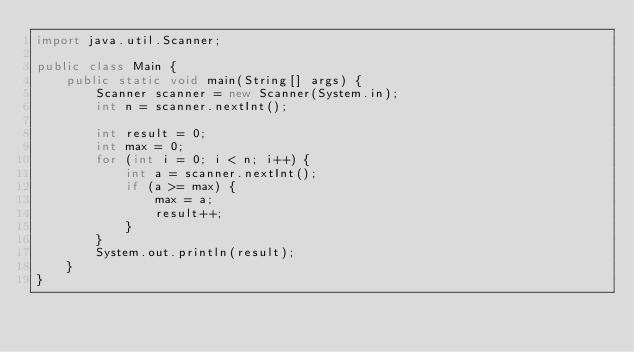<code> <loc_0><loc_0><loc_500><loc_500><_Java_>import java.util.Scanner;

public class Main {
    public static void main(String[] args) {
        Scanner scanner = new Scanner(System.in);
        int n = scanner.nextInt();

        int result = 0;
        int max = 0;
        for (int i = 0; i < n; i++) {
            int a = scanner.nextInt();
            if (a >= max) {
                max = a;
                result++;
            }
        }
        System.out.println(result);
    }
}
</code> 